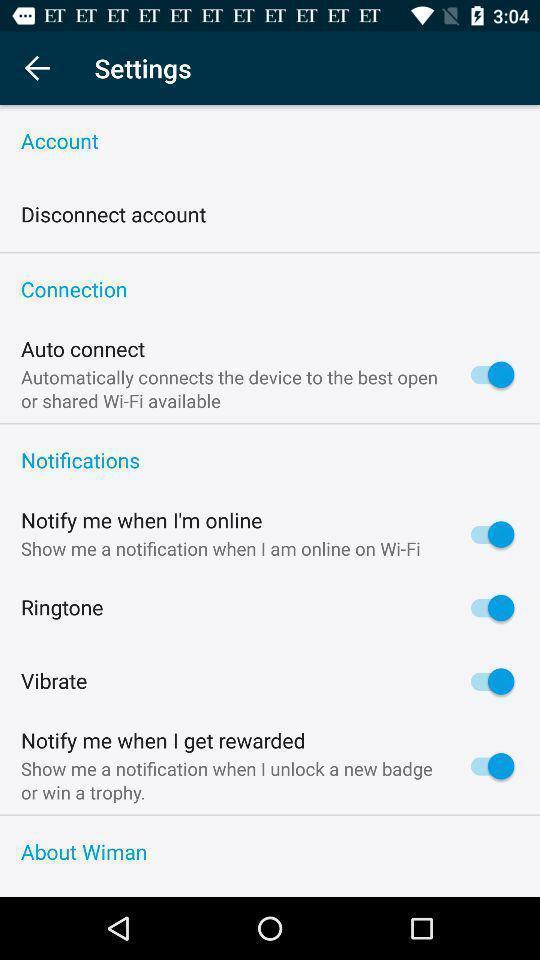Tell me what you see in this picture. Screen showing the settings. 